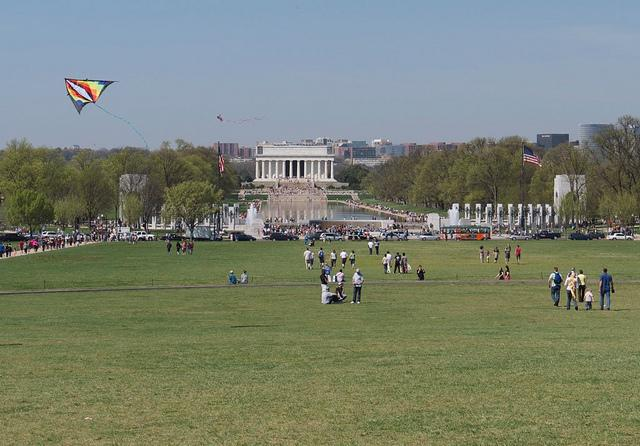In which country is this park located?

Choices:
A) united states
B) venezuela
C) mexico
D) canada united states 